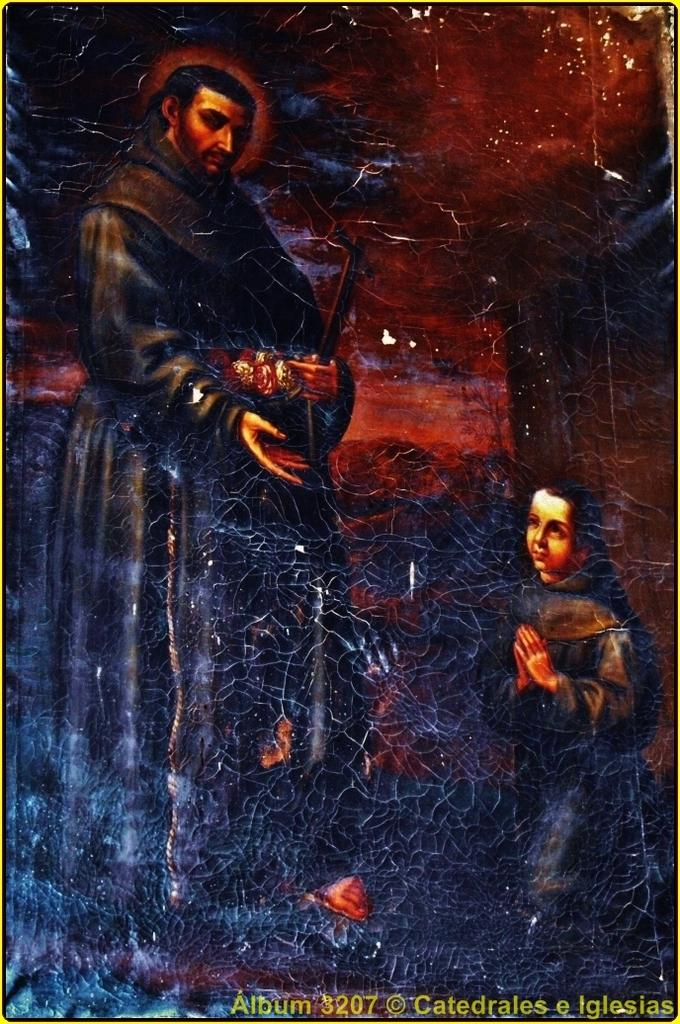<image>
Relay a brief, clear account of the picture shown. A cracked image of a praying child is from Album 3207. 